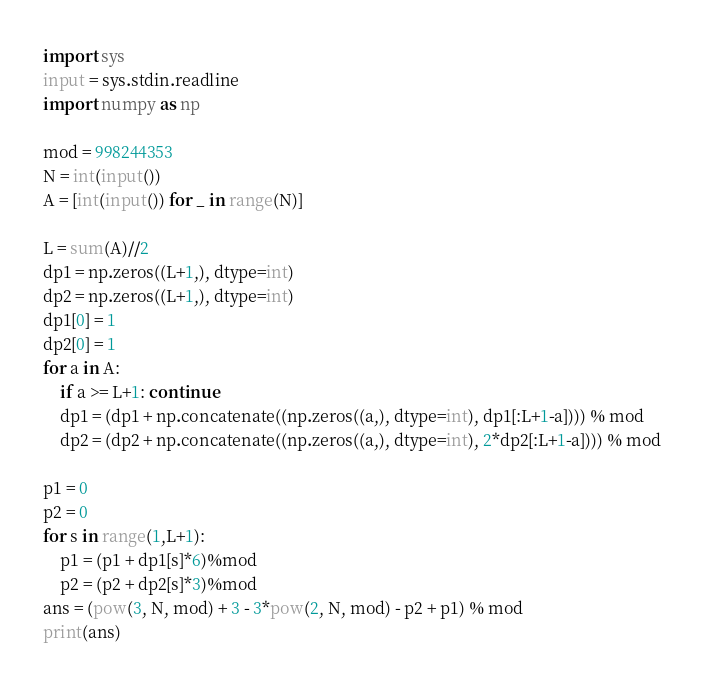Convert code to text. <code><loc_0><loc_0><loc_500><loc_500><_Python_>import sys
input = sys.stdin.readline
import numpy as np

mod = 998244353
N = int(input())
A = [int(input()) for _ in range(N)]

L = sum(A)//2
dp1 = np.zeros((L+1,), dtype=int)
dp2 = np.zeros((L+1,), dtype=int)
dp1[0] = 1
dp2[0] = 1
for a in A:
    if a >= L+1: continue
    dp1 = (dp1 + np.concatenate((np.zeros((a,), dtype=int), dp1[:L+1-a]))) % mod
    dp2 = (dp2 + np.concatenate((np.zeros((a,), dtype=int), 2*dp2[:L+1-a]))) % mod

p1 = 0
p2 = 0
for s in range(1,L+1):
    p1 = (p1 + dp1[s]*6)%mod
    p2 = (p2 + dp2[s]*3)%mod
ans = (pow(3, N, mod) + 3 - 3*pow(2, N, mod) - p2 + p1) % mod
print(ans)</code> 